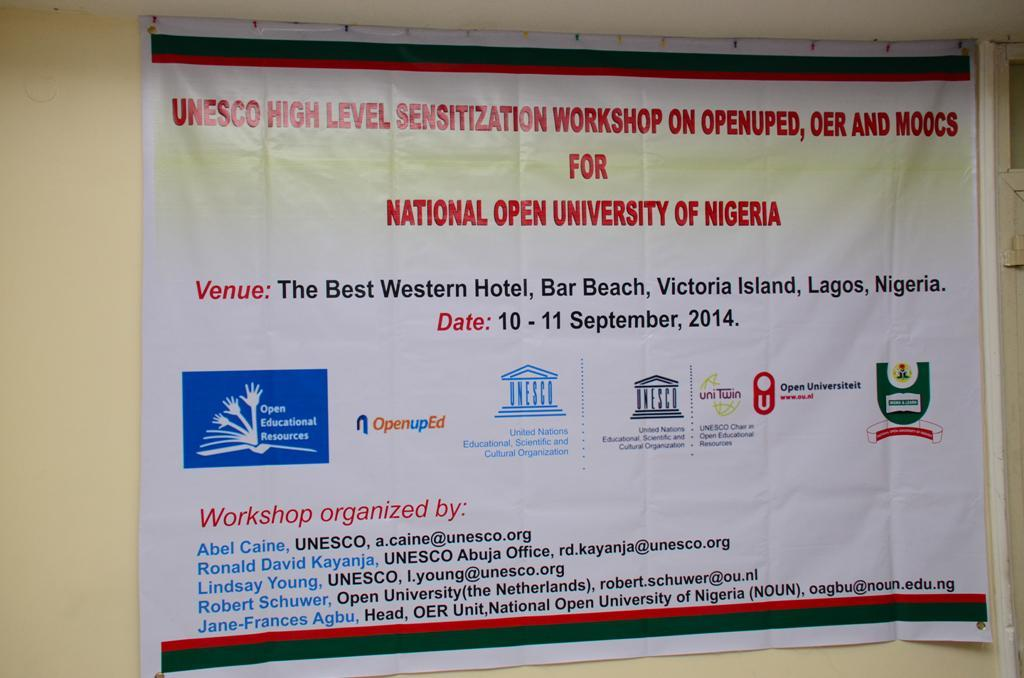<image>
Present a compact description of the photo's key features. A poster for a Senzitization Workshop of the National Open University of Nigeria. 